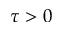Convert formula to latex. <formula><loc_0><loc_0><loc_500><loc_500>\tau > 0</formula> 